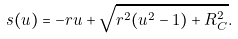<formula> <loc_0><loc_0><loc_500><loc_500>s ( u ) = - r u + \sqrt { r ^ { 2 } ( u ^ { 2 } - 1 ) + R _ { C } ^ { 2 } } .</formula> 